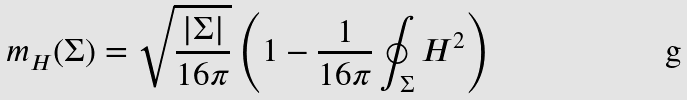<formula> <loc_0><loc_0><loc_500><loc_500>m _ { H } ( \Sigma ) = \sqrt { \frac { | \Sigma | } { 1 6 \pi } } \left ( 1 - \frac { 1 } { 1 6 \pi } \oint _ { \Sigma } H ^ { 2 } \right )</formula> 